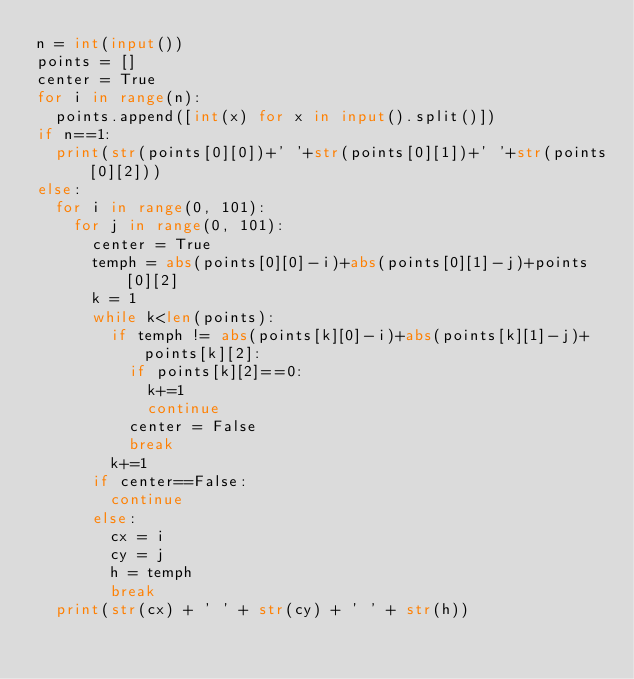<code> <loc_0><loc_0><loc_500><loc_500><_Python_>n = int(input())
points = []
center = True
for i in range(n):
  points.append([int(x) for x in input().split()])
if n==1:
  print(str(points[0][0])+' '+str(points[0][1])+' '+str(points[0][2]))
else:
  for i in range(0, 101):
    for j in range(0, 101):
      center = True
      temph = abs(points[0][0]-i)+abs(points[0][1]-j)+points[0][2]
      k = 1
      while k<len(points):
        if temph != abs(points[k][0]-i)+abs(points[k][1]-j)+points[k][2]:
          if points[k][2]==0:
            k+=1
            continue
          center = False
          break
        k+=1
      if center==False:
        continue
      else:
        cx = i
        cy = j
        h = temph
        break
  print(str(cx) + ' ' + str(cy) + ' ' + str(h))

</code> 